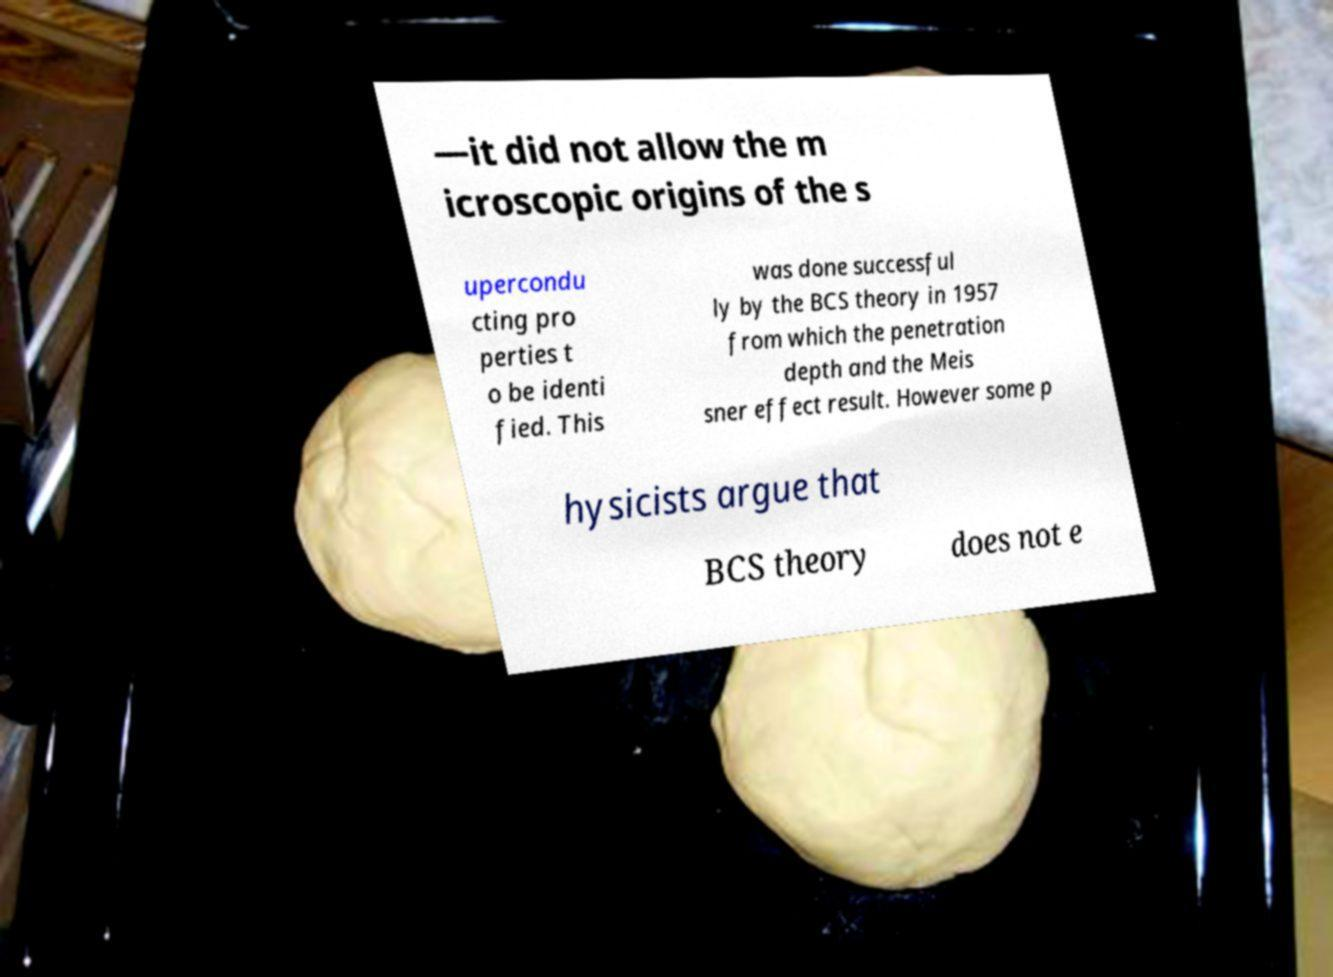Please read and relay the text visible in this image. What does it say? —it did not allow the m icroscopic origins of the s upercondu cting pro perties t o be identi fied. This was done successful ly by the BCS theory in 1957 from which the penetration depth and the Meis sner effect result. However some p hysicists argue that BCS theory does not e 